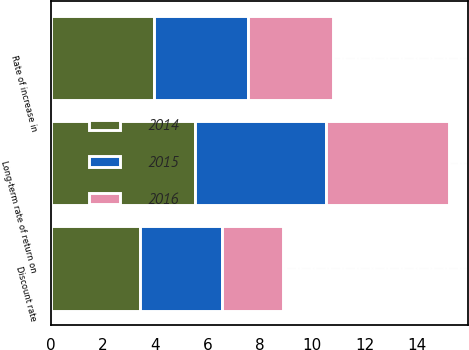Convert chart. <chart><loc_0><loc_0><loc_500><loc_500><stacked_bar_chart><ecel><fcel>Discount rate<fcel>Rate of increase in<fcel>Long-term rate of return on<nl><fcel>2016<fcel>2.34<fcel>3.22<fcel>4.68<nl><fcel>2015<fcel>3.13<fcel>3.61<fcel>5.03<nl><fcel>2014<fcel>3.4<fcel>3.95<fcel>5.51<nl></chart> 